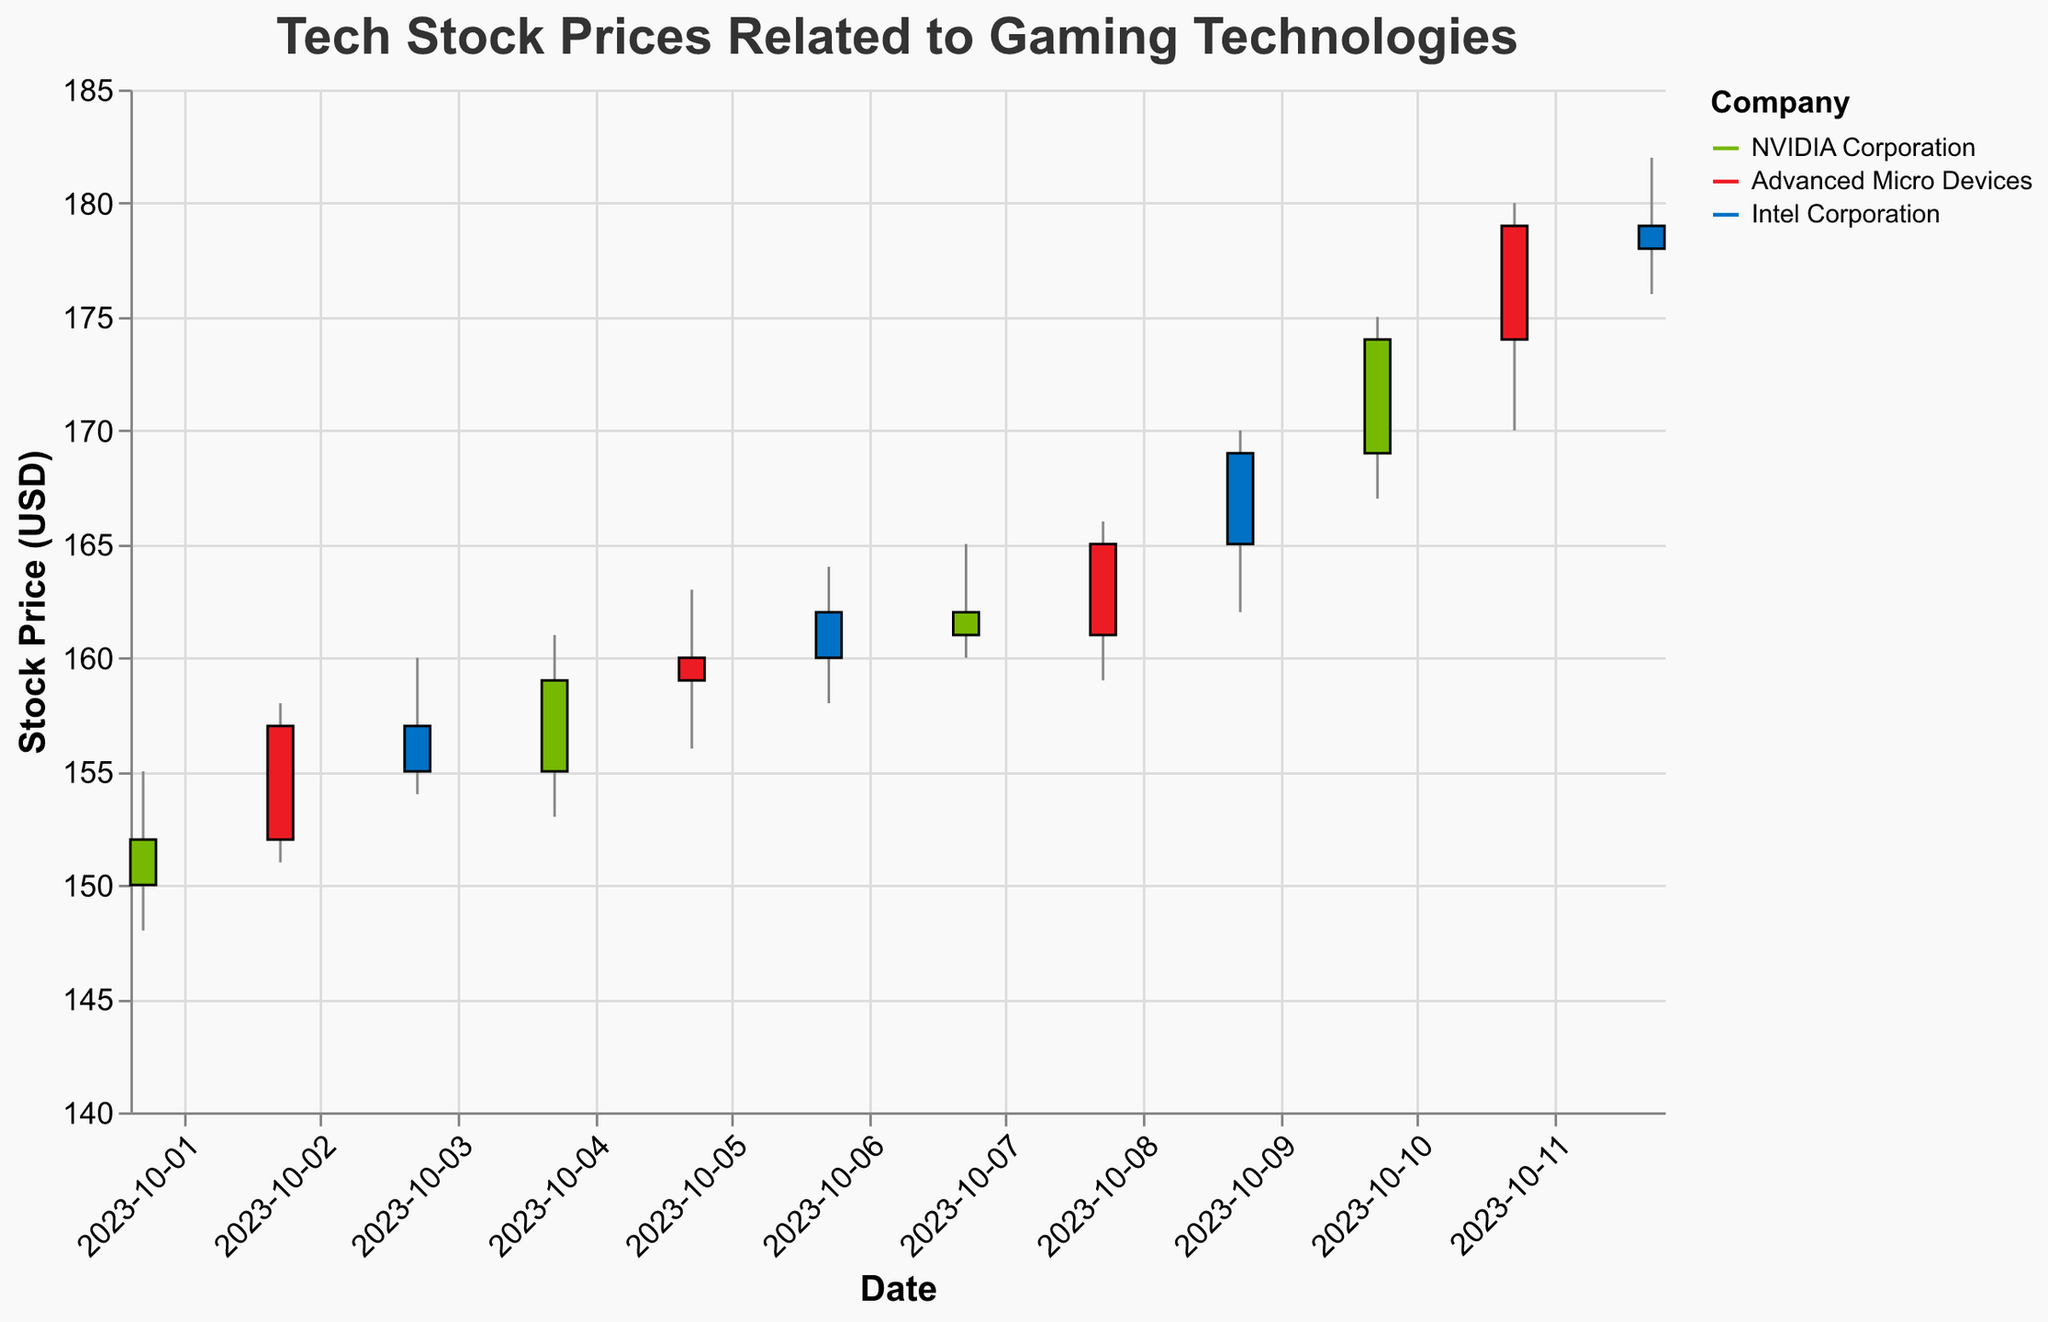What's the title of the chart? The title is directly visible at the top of the chart.
Answer: Tech Stock Prices Related to Gaming Technologies What is the stock price range for Intel Corporation on October 9, 2023? To find the stock price range, look at the "Low" and "High" values for Intel Corporation on October 9, 2023. The low is $162.00 and the high is $170.00.
Answer: $162.00 - $170.00 Which company had the highest closing price on October 11, 2023? Check the "Close" values for each company on October 11, 2023. AMD (Advanced Micro Devices) has a closing price of $179.00, which is the highest among the companies.
Answer: Advanced Micro Devices What was the price difference for NVIDIA Corporation between October 1 and October 10, 2023? Look at the closing prices for NVIDIA Corporation on October 1 ($152.00) and October 10 ($174.00). The difference is $174.00 - $152.00.
Answer: $22.00 Which company showed the smallest daily price range, and on what date? The "daily price range" is the difference between the "High" and "Low" prices for each day. Compare the values for all companies across all dates. The smallest range is $3.00 for NVIDIA Corporation on October 7, 2023 ($165.00 - $162.00).
Answer: NVIDIA Corporation on October 7, 2023 How did the closing price of Advanced Micro Devices change from October 2 to October 5, 2023? Check the closing prices for Advanced Micro Devices on October 2 ($157.00) and October 5 ($160.00). The closing price increased by $3.00 ($160.00 - $157.00).
Answer: Increased by $3.00 What is the average closing price of Intel Corporation over the given dates? Add up the closing prices for Intel Corporation on October 3, 6, 9, and 12, then divide by the number of days. ($155.00 + $162.00 + $169.00 + $178.00) / 4 = $664.00 / 4. The average is $166.00.
Answer: $166.00 On which date did NVIDIA Corporation have the highest closing price and what was it? Look for the highest "Close" value for NVIDIA Corporation across the dates. The highest closing price was on October 10, 2023, at $174.00.
Answer: October 10, 2023, at $174.00 Comparing October 2 and October 8, 2023, which company experienced a larger increase in its closing price? Find the closing prices for each company on October 2 and October 8, for Advanced Micro Devices ($157.00 to $165.00 = $8.00 increase) and Intel Corporation ($155.00 to $178.00). The larger increase was $8.00 for Advanced Micro Devices.
Answer: Advanced Micro Devices 